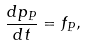<formula> <loc_0><loc_0><loc_500><loc_500>\frac { d p _ { P } } { d t } = f _ { P } ,</formula> 